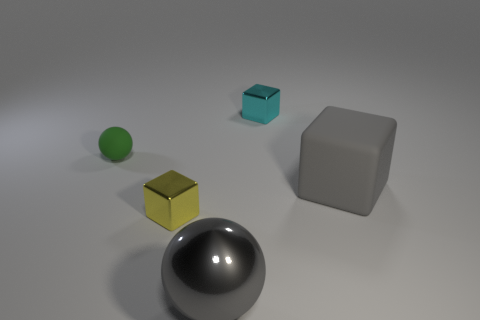Subtract all large blocks. How many blocks are left? 2 Subtract all green balls. How many balls are left? 1 Add 4 big rubber blocks. How many big rubber blocks are left? 5 Add 1 yellow rubber cubes. How many yellow rubber cubes exist? 1 Add 4 gray spheres. How many objects exist? 9 Subtract 0 blue cylinders. How many objects are left? 5 Subtract all spheres. How many objects are left? 3 Subtract all green spheres. Subtract all red cylinders. How many spheres are left? 1 Subtract all red balls. How many purple blocks are left? 0 Subtract all large gray cubes. Subtract all yellow things. How many objects are left? 3 